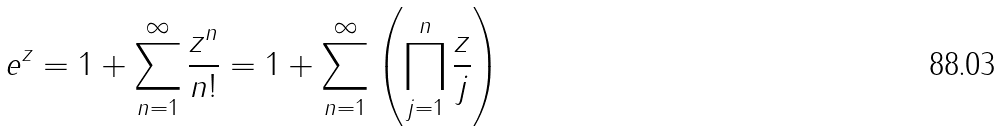Convert formula to latex. <formula><loc_0><loc_0><loc_500><loc_500>e ^ { z } = 1 + \sum _ { n = 1 } ^ { \infty } { \frac { z ^ { n } } { n ! } } = 1 + \sum _ { n = 1 } ^ { \infty } \left ( \prod _ { j = 1 } ^ { n } { \frac { z } { j } } \right )</formula> 